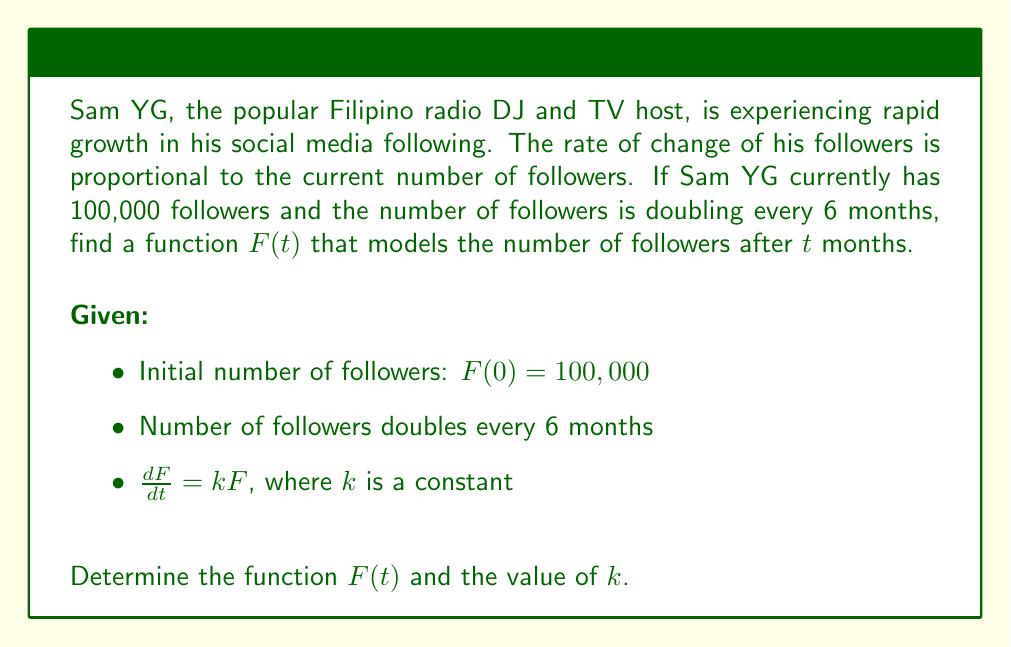Can you solve this math problem? Let's solve this step-by-step:

1) We're given that $\frac{dF}{dt} = kF$. This is a separable differential equation.

2) Separate the variables:
   $$\frac{dF}{F} = k dt$$

3) Integrate both sides:
   $$\int \frac{dF}{F} = \int k dt$$
   $$\ln|F| = kt + C$$

4) Exponentiate both sides:
   $$F = e^{kt + C} = e^C \cdot e^{kt} = Ae^{kt}$$
   where $A = e^C$ is a constant.

5) Use the initial condition $F(0) = 100,000$:
   $$100,000 = Ae^{k(0)} = A$$

6) So our general solution is:
   $$F(t) = 100,000e^{kt}$$

7) Now, we need to find $k$. We know that the number of followers doubles every 6 months:
   $$F(6) = 2F(0)$$
   $$100,000e^{6k} = 2(100,000)$$
   $$e^{6k} = 2$$

8) Take the natural log of both sides:
   $$6k = \ln(2)$$
   $$k = \frac{\ln(2)}{6} \approx 0.1155$$

9) Therefore, the final function is:
   $$F(t) = 100,000e^{\frac{\ln(2)}{6}t}$$
Answer: $F(t) = 100,000e^{\frac{\ln(2)}{6}t}$, $k = \frac{\ln(2)}{6}$ 